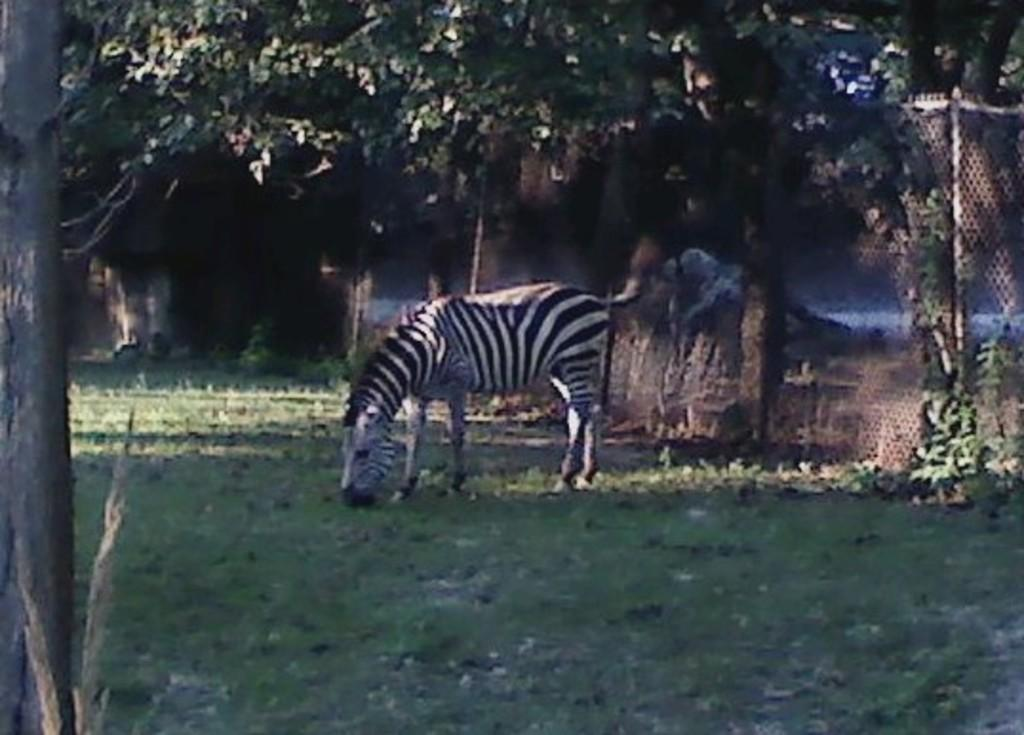What type of vegetation is visible in the image? There is grass in the image. What type of animal can be seen in the image? There is a zebra in the image. What other natural elements are present in the image? There are trees in the image. What type of man-made structures can be seen in the image? There is a wall and a fence in the image. What type of friction can be observed between the zebra and the grass in the image? There is no indication of friction between the zebra and the grass in the image. What type of cheese is being served on the vacation in the image? There is no cheese or vacation present in the image. 